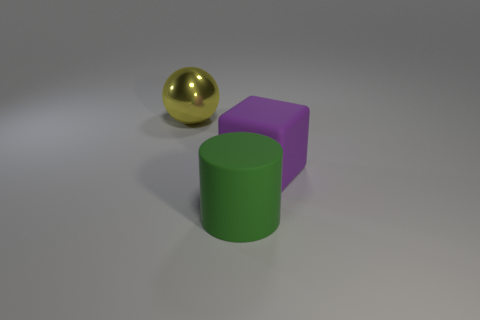Do the thing that is behind the purple cube and the big cylinder that is in front of the purple matte block have the same material?
Give a very brief answer. No. The other thing that is the same material as the green thing is what size?
Give a very brief answer. Large. What shape is the rubber thing in front of the big purple cube?
Provide a succinct answer. Cylinder. Is there a large yellow matte cylinder?
Offer a terse response. No. There is a large rubber thing that is right of the big object in front of the thing right of the matte cylinder; what is its shape?
Your answer should be very brief. Cube. What number of big cylinders are on the right side of the yellow metallic thing?
Your response must be concise. 1. Is the big thing in front of the large purple thing made of the same material as the large yellow thing?
Make the answer very short. No. What number of other things are the same shape as the large purple matte thing?
Your response must be concise. 0. What number of large purple blocks are behind the big rubber thing behind the rubber thing left of the large purple object?
Your response must be concise. 0. There is a big thing right of the green matte thing; what color is it?
Keep it short and to the point. Purple. 